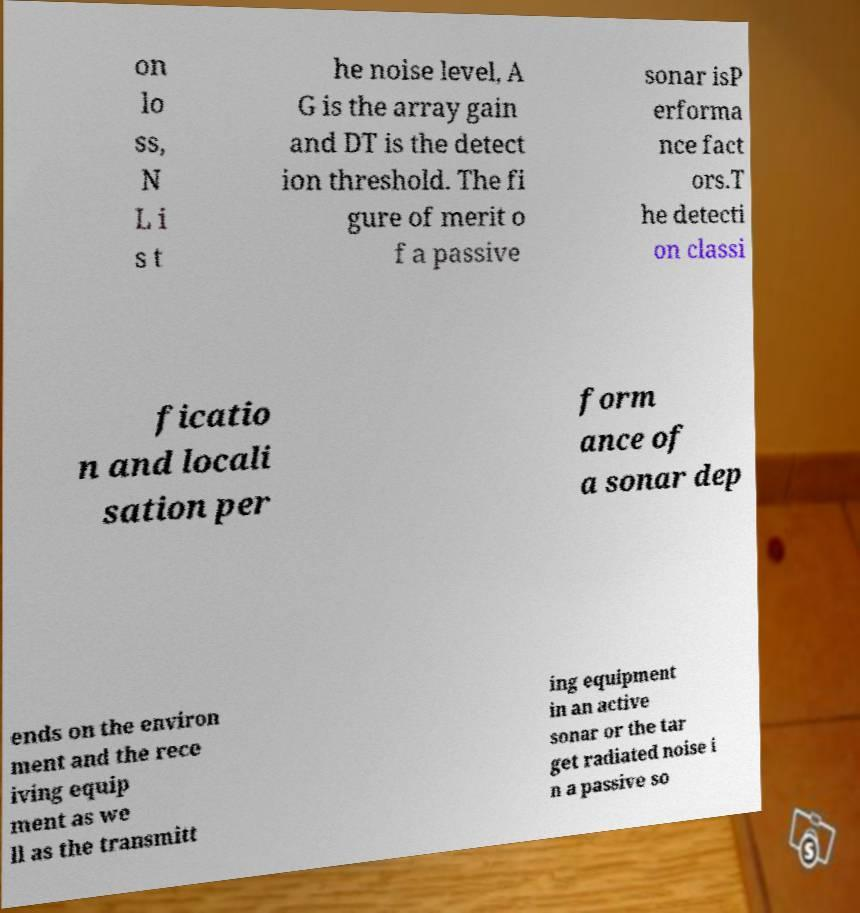There's text embedded in this image that I need extracted. Can you transcribe it verbatim? on lo ss, N L i s t he noise level, A G is the array gain and DT is the detect ion threshold. The fi gure of merit o f a passive sonar isP erforma nce fact ors.T he detecti on classi ficatio n and locali sation per form ance of a sonar dep ends on the environ ment and the rece iving equip ment as we ll as the transmitt ing equipment in an active sonar or the tar get radiated noise i n a passive so 